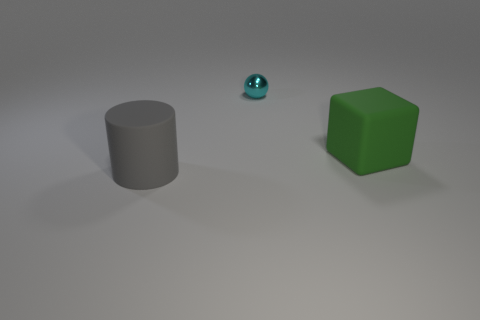Add 2 green rubber blocks. How many objects exist? 5 Subtract all balls. How many objects are left? 2 Subtract 1 green blocks. How many objects are left? 2 Subtract all yellow shiny cylinders. Subtract all big rubber things. How many objects are left? 1 Add 2 metallic balls. How many metallic balls are left? 3 Add 3 large green cubes. How many large green cubes exist? 4 